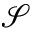Convert formula to latex. <formula><loc_0><loc_0><loc_500><loc_500>{ \mathcal { S } }</formula> 